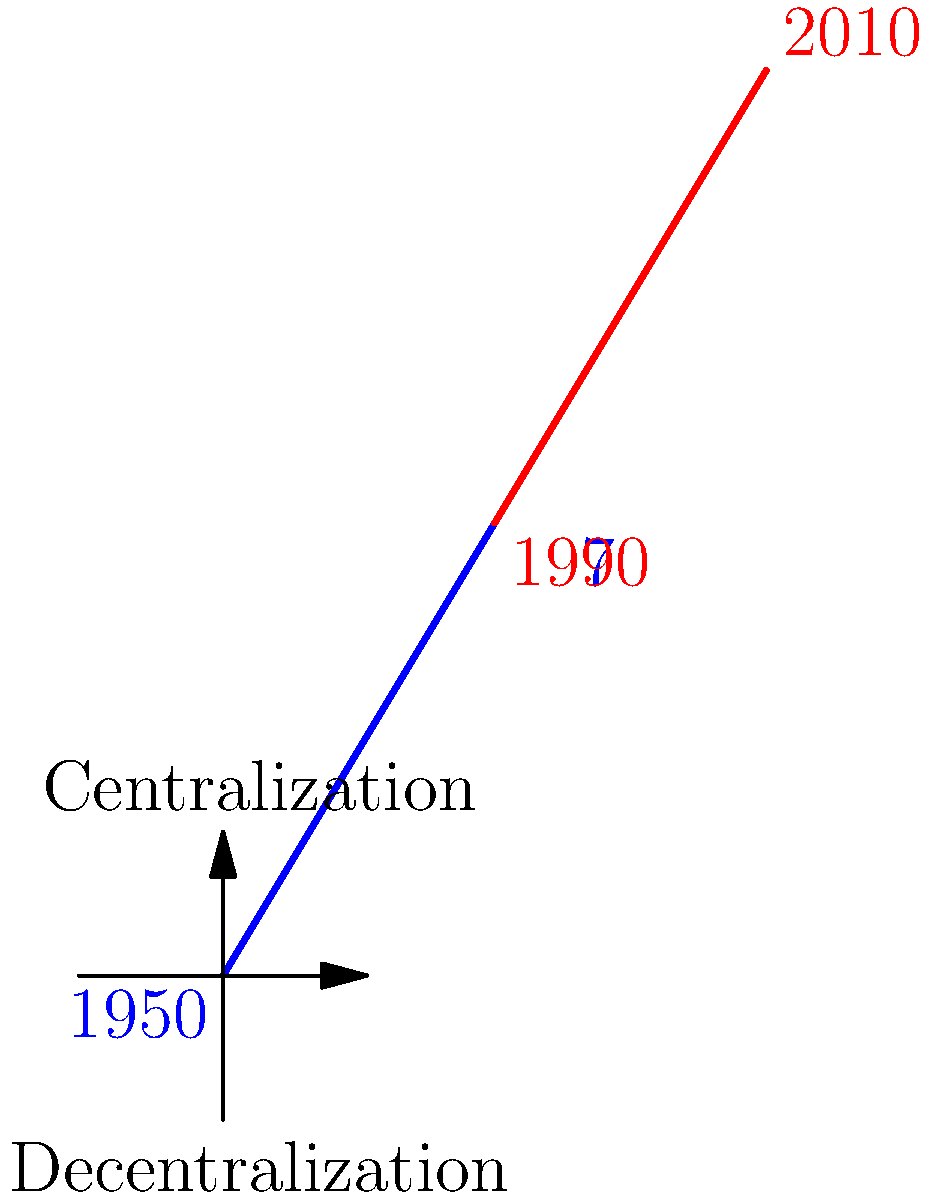Based on the spiral coordinate representation of Swedish governmental power distribution from 1950 to 2010, which period showed a stronger trend towards decentralization? To answer this question, we need to analyze the spiral coordinate graph representing the centralization and decentralization of Swedish governmental power from 1950 to 2010. Let's break it down step-by-step:

1. The graph is divided into two spirals:
   - Blue spiral: representing the period from 1950 to 1970
   - Red spiral: representing the period from 1990 to 2010

2. The vertical axis represents the degree of centralization (upper half) or decentralization (lower half).

3. Analyzing the blue spiral (1950-1970):
   - It starts closer to the center and moves outward.
   - It remains mostly in the upper half of the graph.
   - This indicates a trend towards increased centralization during this period.

4. Analyzing the red spiral (1990-2010):
   - It starts where the blue spiral ends and continues to move outward.
   - It crosses into the lower half of the graph and remains there.
   - This indicates a clear trend towards decentralization during this period.

5. Comparing the two periods:
   - The 1950-1970 period shows a trend towards centralization.
   - The 1990-2010 period shows a stronger and more consistent trend towards decentralization.

Therefore, based on this spiral coordinate representation, the period from 1990 to 2010 showed a stronger trend towards decentralization of Swedish governmental power.
Answer: 1990-2010 